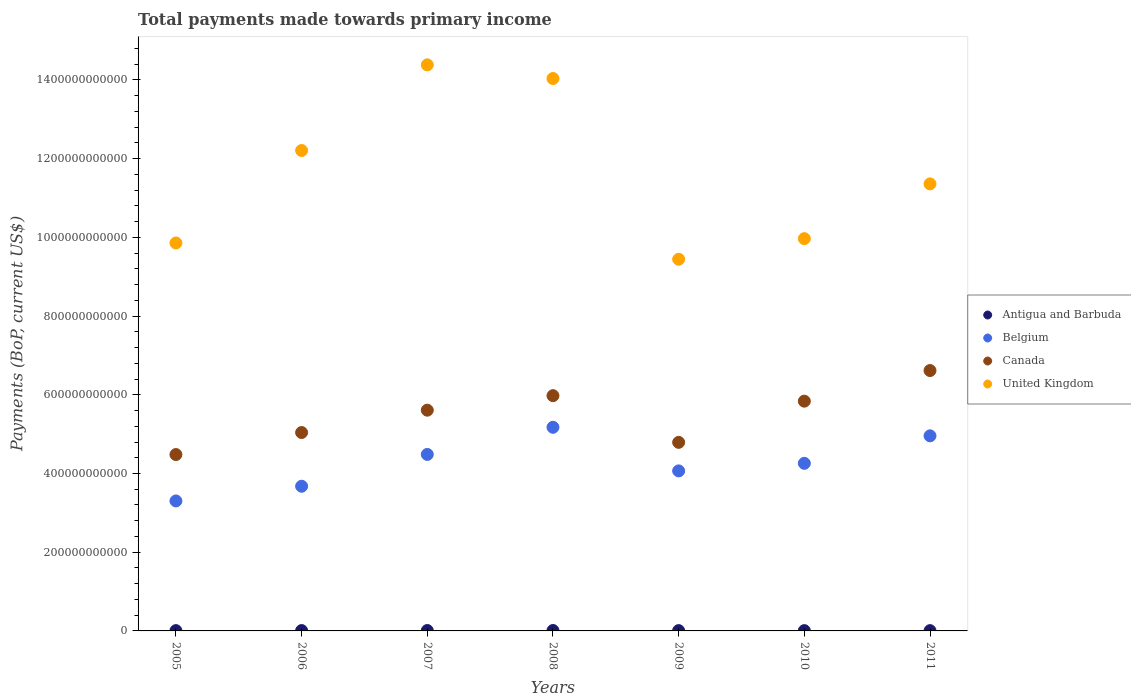How many different coloured dotlines are there?
Keep it short and to the point. 4. Is the number of dotlines equal to the number of legend labels?
Provide a succinct answer. Yes. What is the total payments made towards primary income in Belgium in 2005?
Ensure brevity in your answer.  3.30e+11. Across all years, what is the maximum total payments made towards primary income in Antigua and Barbuda?
Keep it short and to the point. 1.03e+09. Across all years, what is the minimum total payments made towards primary income in Antigua and Barbuda?
Your answer should be compact. 6.91e+08. In which year was the total payments made towards primary income in Canada minimum?
Make the answer very short. 2005. What is the total total payments made towards primary income in United Kingdom in the graph?
Make the answer very short. 8.13e+12. What is the difference between the total payments made towards primary income in Antigua and Barbuda in 2007 and that in 2010?
Your answer should be compact. 2.89e+08. What is the difference between the total payments made towards primary income in Belgium in 2006 and the total payments made towards primary income in United Kingdom in 2007?
Your answer should be very brief. -1.07e+12. What is the average total payments made towards primary income in Antigua and Barbuda per year?
Ensure brevity in your answer.  8.37e+08. In the year 2005, what is the difference between the total payments made towards primary income in Canada and total payments made towards primary income in Antigua and Barbuda?
Make the answer very short. 4.47e+11. In how many years, is the total payments made towards primary income in United Kingdom greater than 1440000000000 US$?
Provide a succinct answer. 0. What is the ratio of the total payments made towards primary income in United Kingdom in 2006 to that in 2011?
Give a very brief answer. 1.07. Is the total payments made towards primary income in Canada in 2006 less than that in 2007?
Ensure brevity in your answer.  Yes. What is the difference between the highest and the second highest total payments made towards primary income in Belgium?
Ensure brevity in your answer.  2.17e+1. What is the difference between the highest and the lowest total payments made towards primary income in United Kingdom?
Provide a succinct answer. 4.94e+11. In how many years, is the total payments made towards primary income in United Kingdom greater than the average total payments made towards primary income in United Kingdom taken over all years?
Provide a succinct answer. 3. Is it the case that in every year, the sum of the total payments made towards primary income in Antigua and Barbuda and total payments made towards primary income in United Kingdom  is greater than the total payments made towards primary income in Belgium?
Make the answer very short. Yes. Is the total payments made towards primary income in Canada strictly greater than the total payments made towards primary income in United Kingdom over the years?
Make the answer very short. No. How many years are there in the graph?
Offer a terse response. 7. What is the difference between two consecutive major ticks on the Y-axis?
Your answer should be very brief. 2.00e+11. Are the values on the major ticks of Y-axis written in scientific E-notation?
Keep it short and to the point. No. Does the graph contain any zero values?
Your answer should be very brief. No. Does the graph contain grids?
Give a very brief answer. No. Where does the legend appear in the graph?
Keep it short and to the point. Center right. How many legend labels are there?
Provide a short and direct response. 4. What is the title of the graph?
Provide a short and direct response. Total payments made towards primary income. What is the label or title of the Y-axis?
Offer a very short reply. Payments (BoP, current US$). What is the Payments (BoP, current US$) in Antigua and Barbuda in 2005?
Provide a short and direct response. 7.43e+08. What is the Payments (BoP, current US$) of Belgium in 2005?
Give a very brief answer. 3.30e+11. What is the Payments (BoP, current US$) in Canada in 2005?
Give a very brief answer. 4.48e+11. What is the Payments (BoP, current US$) of United Kingdom in 2005?
Provide a succinct answer. 9.86e+11. What is the Payments (BoP, current US$) in Antigua and Barbuda in 2006?
Give a very brief answer. 8.92e+08. What is the Payments (BoP, current US$) in Belgium in 2006?
Your answer should be compact. 3.68e+11. What is the Payments (BoP, current US$) in Canada in 2006?
Offer a very short reply. 5.04e+11. What is the Payments (BoP, current US$) of United Kingdom in 2006?
Offer a very short reply. 1.22e+12. What is the Payments (BoP, current US$) of Antigua and Barbuda in 2007?
Your answer should be compact. 1.01e+09. What is the Payments (BoP, current US$) in Belgium in 2007?
Your answer should be very brief. 4.48e+11. What is the Payments (BoP, current US$) in Canada in 2007?
Offer a very short reply. 5.61e+11. What is the Payments (BoP, current US$) in United Kingdom in 2007?
Make the answer very short. 1.44e+12. What is the Payments (BoP, current US$) in Antigua and Barbuda in 2008?
Ensure brevity in your answer.  1.03e+09. What is the Payments (BoP, current US$) of Belgium in 2008?
Keep it short and to the point. 5.17e+11. What is the Payments (BoP, current US$) of Canada in 2008?
Provide a succinct answer. 5.98e+11. What is the Payments (BoP, current US$) of United Kingdom in 2008?
Your response must be concise. 1.40e+12. What is the Payments (BoP, current US$) in Antigua and Barbuda in 2009?
Your answer should be compact. 7.70e+08. What is the Payments (BoP, current US$) in Belgium in 2009?
Your answer should be very brief. 4.07e+11. What is the Payments (BoP, current US$) in Canada in 2009?
Offer a terse response. 4.79e+11. What is the Payments (BoP, current US$) in United Kingdom in 2009?
Make the answer very short. 9.44e+11. What is the Payments (BoP, current US$) of Antigua and Barbuda in 2010?
Your response must be concise. 7.22e+08. What is the Payments (BoP, current US$) in Belgium in 2010?
Provide a short and direct response. 4.26e+11. What is the Payments (BoP, current US$) of Canada in 2010?
Provide a succinct answer. 5.84e+11. What is the Payments (BoP, current US$) in United Kingdom in 2010?
Ensure brevity in your answer.  9.97e+11. What is the Payments (BoP, current US$) of Antigua and Barbuda in 2011?
Your response must be concise. 6.91e+08. What is the Payments (BoP, current US$) in Belgium in 2011?
Offer a terse response. 4.96e+11. What is the Payments (BoP, current US$) of Canada in 2011?
Your response must be concise. 6.62e+11. What is the Payments (BoP, current US$) in United Kingdom in 2011?
Make the answer very short. 1.14e+12. Across all years, what is the maximum Payments (BoP, current US$) of Antigua and Barbuda?
Your answer should be compact. 1.03e+09. Across all years, what is the maximum Payments (BoP, current US$) in Belgium?
Ensure brevity in your answer.  5.17e+11. Across all years, what is the maximum Payments (BoP, current US$) of Canada?
Make the answer very short. 6.62e+11. Across all years, what is the maximum Payments (BoP, current US$) in United Kingdom?
Provide a short and direct response. 1.44e+12. Across all years, what is the minimum Payments (BoP, current US$) of Antigua and Barbuda?
Keep it short and to the point. 6.91e+08. Across all years, what is the minimum Payments (BoP, current US$) of Belgium?
Offer a very short reply. 3.30e+11. Across all years, what is the minimum Payments (BoP, current US$) in Canada?
Give a very brief answer. 4.48e+11. Across all years, what is the minimum Payments (BoP, current US$) of United Kingdom?
Keep it short and to the point. 9.44e+11. What is the total Payments (BoP, current US$) in Antigua and Barbuda in the graph?
Provide a succinct answer. 5.86e+09. What is the total Payments (BoP, current US$) of Belgium in the graph?
Make the answer very short. 2.99e+12. What is the total Payments (BoP, current US$) in Canada in the graph?
Provide a short and direct response. 3.84e+12. What is the total Payments (BoP, current US$) of United Kingdom in the graph?
Your answer should be compact. 8.13e+12. What is the difference between the Payments (BoP, current US$) in Antigua and Barbuda in 2005 and that in 2006?
Your answer should be very brief. -1.49e+08. What is the difference between the Payments (BoP, current US$) in Belgium in 2005 and that in 2006?
Provide a succinct answer. -3.73e+1. What is the difference between the Payments (BoP, current US$) in Canada in 2005 and that in 2006?
Provide a short and direct response. -5.59e+1. What is the difference between the Payments (BoP, current US$) of United Kingdom in 2005 and that in 2006?
Provide a succinct answer. -2.35e+11. What is the difference between the Payments (BoP, current US$) of Antigua and Barbuda in 2005 and that in 2007?
Make the answer very short. -2.68e+08. What is the difference between the Payments (BoP, current US$) of Belgium in 2005 and that in 2007?
Your answer should be very brief. -1.18e+11. What is the difference between the Payments (BoP, current US$) in Canada in 2005 and that in 2007?
Ensure brevity in your answer.  -1.13e+11. What is the difference between the Payments (BoP, current US$) of United Kingdom in 2005 and that in 2007?
Make the answer very short. -4.53e+11. What is the difference between the Payments (BoP, current US$) of Antigua and Barbuda in 2005 and that in 2008?
Offer a very short reply. -2.87e+08. What is the difference between the Payments (BoP, current US$) of Belgium in 2005 and that in 2008?
Offer a terse response. -1.87e+11. What is the difference between the Payments (BoP, current US$) in Canada in 2005 and that in 2008?
Offer a terse response. -1.50e+11. What is the difference between the Payments (BoP, current US$) of United Kingdom in 2005 and that in 2008?
Your answer should be very brief. -4.18e+11. What is the difference between the Payments (BoP, current US$) of Antigua and Barbuda in 2005 and that in 2009?
Your answer should be very brief. -2.77e+07. What is the difference between the Payments (BoP, current US$) of Belgium in 2005 and that in 2009?
Make the answer very short. -7.63e+1. What is the difference between the Payments (BoP, current US$) of Canada in 2005 and that in 2009?
Make the answer very short. -3.10e+1. What is the difference between the Payments (BoP, current US$) in United Kingdom in 2005 and that in 2009?
Make the answer very short. 4.14e+1. What is the difference between the Payments (BoP, current US$) of Antigua and Barbuda in 2005 and that in 2010?
Give a very brief answer. 2.12e+07. What is the difference between the Payments (BoP, current US$) of Belgium in 2005 and that in 2010?
Make the answer very short. -9.56e+1. What is the difference between the Payments (BoP, current US$) in Canada in 2005 and that in 2010?
Your response must be concise. -1.36e+11. What is the difference between the Payments (BoP, current US$) of United Kingdom in 2005 and that in 2010?
Offer a very short reply. -1.10e+1. What is the difference between the Payments (BoP, current US$) in Antigua and Barbuda in 2005 and that in 2011?
Offer a terse response. 5.14e+07. What is the difference between the Payments (BoP, current US$) of Belgium in 2005 and that in 2011?
Offer a very short reply. -1.65e+11. What is the difference between the Payments (BoP, current US$) of Canada in 2005 and that in 2011?
Give a very brief answer. -2.13e+11. What is the difference between the Payments (BoP, current US$) of United Kingdom in 2005 and that in 2011?
Offer a terse response. -1.50e+11. What is the difference between the Payments (BoP, current US$) of Antigua and Barbuda in 2006 and that in 2007?
Offer a very short reply. -1.19e+08. What is the difference between the Payments (BoP, current US$) in Belgium in 2006 and that in 2007?
Your answer should be compact. -8.08e+1. What is the difference between the Payments (BoP, current US$) of Canada in 2006 and that in 2007?
Your answer should be compact. -5.68e+1. What is the difference between the Payments (BoP, current US$) of United Kingdom in 2006 and that in 2007?
Your response must be concise. -2.18e+11. What is the difference between the Payments (BoP, current US$) of Antigua and Barbuda in 2006 and that in 2008?
Provide a short and direct response. -1.38e+08. What is the difference between the Payments (BoP, current US$) of Belgium in 2006 and that in 2008?
Provide a succinct answer. -1.50e+11. What is the difference between the Payments (BoP, current US$) of Canada in 2006 and that in 2008?
Offer a very short reply. -9.37e+1. What is the difference between the Payments (BoP, current US$) in United Kingdom in 2006 and that in 2008?
Ensure brevity in your answer.  -1.83e+11. What is the difference between the Payments (BoP, current US$) of Antigua and Barbuda in 2006 and that in 2009?
Give a very brief answer. 1.21e+08. What is the difference between the Payments (BoP, current US$) in Belgium in 2006 and that in 2009?
Your answer should be very brief. -3.90e+1. What is the difference between the Payments (BoP, current US$) of Canada in 2006 and that in 2009?
Your response must be concise. 2.50e+1. What is the difference between the Payments (BoP, current US$) of United Kingdom in 2006 and that in 2009?
Make the answer very short. 2.76e+11. What is the difference between the Payments (BoP, current US$) in Antigua and Barbuda in 2006 and that in 2010?
Make the answer very short. 1.70e+08. What is the difference between the Payments (BoP, current US$) in Belgium in 2006 and that in 2010?
Provide a succinct answer. -5.82e+1. What is the difference between the Payments (BoP, current US$) in Canada in 2006 and that in 2010?
Offer a terse response. -7.97e+1. What is the difference between the Payments (BoP, current US$) of United Kingdom in 2006 and that in 2010?
Give a very brief answer. 2.24e+11. What is the difference between the Payments (BoP, current US$) in Antigua and Barbuda in 2006 and that in 2011?
Provide a succinct answer. 2.01e+08. What is the difference between the Payments (BoP, current US$) of Belgium in 2006 and that in 2011?
Your answer should be compact. -1.28e+11. What is the difference between the Payments (BoP, current US$) of Canada in 2006 and that in 2011?
Offer a terse response. -1.58e+11. What is the difference between the Payments (BoP, current US$) in United Kingdom in 2006 and that in 2011?
Your answer should be very brief. 8.48e+1. What is the difference between the Payments (BoP, current US$) of Antigua and Barbuda in 2007 and that in 2008?
Give a very brief answer. -1.86e+07. What is the difference between the Payments (BoP, current US$) of Belgium in 2007 and that in 2008?
Your answer should be very brief. -6.90e+1. What is the difference between the Payments (BoP, current US$) in Canada in 2007 and that in 2008?
Provide a succinct answer. -3.69e+1. What is the difference between the Payments (BoP, current US$) of United Kingdom in 2007 and that in 2008?
Keep it short and to the point. 3.47e+1. What is the difference between the Payments (BoP, current US$) in Antigua and Barbuda in 2007 and that in 2009?
Your answer should be very brief. 2.40e+08. What is the difference between the Payments (BoP, current US$) of Belgium in 2007 and that in 2009?
Provide a succinct answer. 4.18e+1. What is the difference between the Payments (BoP, current US$) of Canada in 2007 and that in 2009?
Your response must be concise. 8.17e+1. What is the difference between the Payments (BoP, current US$) in United Kingdom in 2007 and that in 2009?
Keep it short and to the point. 4.94e+11. What is the difference between the Payments (BoP, current US$) of Antigua and Barbuda in 2007 and that in 2010?
Provide a succinct answer. 2.89e+08. What is the difference between the Payments (BoP, current US$) in Belgium in 2007 and that in 2010?
Ensure brevity in your answer.  2.26e+1. What is the difference between the Payments (BoP, current US$) of Canada in 2007 and that in 2010?
Offer a terse response. -2.29e+1. What is the difference between the Payments (BoP, current US$) of United Kingdom in 2007 and that in 2010?
Give a very brief answer. 4.42e+11. What is the difference between the Payments (BoP, current US$) of Antigua and Barbuda in 2007 and that in 2011?
Your response must be concise. 3.19e+08. What is the difference between the Payments (BoP, current US$) of Belgium in 2007 and that in 2011?
Your answer should be very brief. -4.73e+1. What is the difference between the Payments (BoP, current US$) in Canada in 2007 and that in 2011?
Give a very brief answer. -1.01e+11. What is the difference between the Payments (BoP, current US$) of United Kingdom in 2007 and that in 2011?
Your answer should be compact. 3.02e+11. What is the difference between the Payments (BoP, current US$) of Antigua and Barbuda in 2008 and that in 2009?
Keep it short and to the point. 2.59e+08. What is the difference between the Payments (BoP, current US$) of Belgium in 2008 and that in 2009?
Make the answer very short. 1.11e+11. What is the difference between the Payments (BoP, current US$) in Canada in 2008 and that in 2009?
Offer a terse response. 1.19e+11. What is the difference between the Payments (BoP, current US$) in United Kingdom in 2008 and that in 2009?
Keep it short and to the point. 4.59e+11. What is the difference between the Payments (BoP, current US$) of Antigua and Barbuda in 2008 and that in 2010?
Offer a very short reply. 3.08e+08. What is the difference between the Payments (BoP, current US$) in Belgium in 2008 and that in 2010?
Your answer should be very brief. 9.16e+1. What is the difference between the Payments (BoP, current US$) in Canada in 2008 and that in 2010?
Your response must be concise. 1.40e+1. What is the difference between the Payments (BoP, current US$) in United Kingdom in 2008 and that in 2010?
Your answer should be compact. 4.07e+11. What is the difference between the Payments (BoP, current US$) of Antigua and Barbuda in 2008 and that in 2011?
Ensure brevity in your answer.  3.38e+08. What is the difference between the Payments (BoP, current US$) of Belgium in 2008 and that in 2011?
Your answer should be compact. 2.17e+1. What is the difference between the Payments (BoP, current US$) in Canada in 2008 and that in 2011?
Ensure brevity in your answer.  -6.38e+1. What is the difference between the Payments (BoP, current US$) of United Kingdom in 2008 and that in 2011?
Your answer should be very brief. 2.68e+11. What is the difference between the Payments (BoP, current US$) in Antigua and Barbuda in 2009 and that in 2010?
Your answer should be compact. 4.88e+07. What is the difference between the Payments (BoP, current US$) of Belgium in 2009 and that in 2010?
Offer a terse response. -1.92e+1. What is the difference between the Payments (BoP, current US$) of Canada in 2009 and that in 2010?
Make the answer very short. -1.05e+11. What is the difference between the Payments (BoP, current US$) in United Kingdom in 2009 and that in 2010?
Offer a terse response. -5.24e+1. What is the difference between the Payments (BoP, current US$) in Antigua and Barbuda in 2009 and that in 2011?
Provide a short and direct response. 7.91e+07. What is the difference between the Payments (BoP, current US$) of Belgium in 2009 and that in 2011?
Your answer should be very brief. -8.91e+1. What is the difference between the Payments (BoP, current US$) in Canada in 2009 and that in 2011?
Make the answer very short. -1.82e+11. What is the difference between the Payments (BoP, current US$) in United Kingdom in 2009 and that in 2011?
Your answer should be compact. -1.92e+11. What is the difference between the Payments (BoP, current US$) in Antigua and Barbuda in 2010 and that in 2011?
Keep it short and to the point. 3.02e+07. What is the difference between the Payments (BoP, current US$) of Belgium in 2010 and that in 2011?
Provide a short and direct response. -6.99e+1. What is the difference between the Payments (BoP, current US$) of Canada in 2010 and that in 2011?
Keep it short and to the point. -7.78e+1. What is the difference between the Payments (BoP, current US$) of United Kingdom in 2010 and that in 2011?
Ensure brevity in your answer.  -1.39e+11. What is the difference between the Payments (BoP, current US$) in Antigua and Barbuda in 2005 and the Payments (BoP, current US$) in Belgium in 2006?
Your answer should be compact. -3.67e+11. What is the difference between the Payments (BoP, current US$) of Antigua and Barbuda in 2005 and the Payments (BoP, current US$) of Canada in 2006?
Offer a terse response. -5.03e+11. What is the difference between the Payments (BoP, current US$) of Antigua and Barbuda in 2005 and the Payments (BoP, current US$) of United Kingdom in 2006?
Your response must be concise. -1.22e+12. What is the difference between the Payments (BoP, current US$) of Belgium in 2005 and the Payments (BoP, current US$) of Canada in 2006?
Ensure brevity in your answer.  -1.74e+11. What is the difference between the Payments (BoP, current US$) in Belgium in 2005 and the Payments (BoP, current US$) in United Kingdom in 2006?
Your response must be concise. -8.90e+11. What is the difference between the Payments (BoP, current US$) in Canada in 2005 and the Payments (BoP, current US$) in United Kingdom in 2006?
Offer a very short reply. -7.73e+11. What is the difference between the Payments (BoP, current US$) in Antigua and Barbuda in 2005 and the Payments (BoP, current US$) in Belgium in 2007?
Ensure brevity in your answer.  -4.48e+11. What is the difference between the Payments (BoP, current US$) of Antigua and Barbuda in 2005 and the Payments (BoP, current US$) of Canada in 2007?
Provide a short and direct response. -5.60e+11. What is the difference between the Payments (BoP, current US$) of Antigua and Barbuda in 2005 and the Payments (BoP, current US$) of United Kingdom in 2007?
Offer a very short reply. -1.44e+12. What is the difference between the Payments (BoP, current US$) of Belgium in 2005 and the Payments (BoP, current US$) of Canada in 2007?
Keep it short and to the point. -2.31e+11. What is the difference between the Payments (BoP, current US$) in Belgium in 2005 and the Payments (BoP, current US$) in United Kingdom in 2007?
Keep it short and to the point. -1.11e+12. What is the difference between the Payments (BoP, current US$) of Canada in 2005 and the Payments (BoP, current US$) of United Kingdom in 2007?
Your response must be concise. -9.90e+11. What is the difference between the Payments (BoP, current US$) of Antigua and Barbuda in 2005 and the Payments (BoP, current US$) of Belgium in 2008?
Your response must be concise. -5.17e+11. What is the difference between the Payments (BoP, current US$) of Antigua and Barbuda in 2005 and the Payments (BoP, current US$) of Canada in 2008?
Make the answer very short. -5.97e+11. What is the difference between the Payments (BoP, current US$) in Antigua and Barbuda in 2005 and the Payments (BoP, current US$) in United Kingdom in 2008?
Make the answer very short. -1.40e+12. What is the difference between the Payments (BoP, current US$) of Belgium in 2005 and the Payments (BoP, current US$) of Canada in 2008?
Offer a very short reply. -2.67e+11. What is the difference between the Payments (BoP, current US$) in Belgium in 2005 and the Payments (BoP, current US$) in United Kingdom in 2008?
Provide a short and direct response. -1.07e+12. What is the difference between the Payments (BoP, current US$) of Canada in 2005 and the Payments (BoP, current US$) of United Kingdom in 2008?
Ensure brevity in your answer.  -9.55e+11. What is the difference between the Payments (BoP, current US$) of Antigua and Barbuda in 2005 and the Payments (BoP, current US$) of Belgium in 2009?
Provide a short and direct response. -4.06e+11. What is the difference between the Payments (BoP, current US$) in Antigua and Barbuda in 2005 and the Payments (BoP, current US$) in Canada in 2009?
Provide a short and direct response. -4.78e+11. What is the difference between the Payments (BoP, current US$) in Antigua and Barbuda in 2005 and the Payments (BoP, current US$) in United Kingdom in 2009?
Give a very brief answer. -9.44e+11. What is the difference between the Payments (BoP, current US$) of Belgium in 2005 and the Payments (BoP, current US$) of Canada in 2009?
Your response must be concise. -1.49e+11. What is the difference between the Payments (BoP, current US$) in Belgium in 2005 and the Payments (BoP, current US$) in United Kingdom in 2009?
Provide a succinct answer. -6.14e+11. What is the difference between the Payments (BoP, current US$) in Canada in 2005 and the Payments (BoP, current US$) in United Kingdom in 2009?
Ensure brevity in your answer.  -4.96e+11. What is the difference between the Payments (BoP, current US$) of Antigua and Barbuda in 2005 and the Payments (BoP, current US$) of Belgium in 2010?
Your answer should be very brief. -4.25e+11. What is the difference between the Payments (BoP, current US$) of Antigua and Barbuda in 2005 and the Payments (BoP, current US$) of Canada in 2010?
Offer a terse response. -5.83e+11. What is the difference between the Payments (BoP, current US$) in Antigua and Barbuda in 2005 and the Payments (BoP, current US$) in United Kingdom in 2010?
Ensure brevity in your answer.  -9.96e+11. What is the difference between the Payments (BoP, current US$) of Belgium in 2005 and the Payments (BoP, current US$) of Canada in 2010?
Your response must be concise. -2.54e+11. What is the difference between the Payments (BoP, current US$) in Belgium in 2005 and the Payments (BoP, current US$) in United Kingdom in 2010?
Make the answer very short. -6.66e+11. What is the difference between the Payments (BoP, current US$) of Canada in 2005 and the Payments (BoP, current US$) of United Kingdom in 2010?
Provide a succinct answer. -5.49e+11. What is the difference between the Payments (BoP, current US$) in Antigua and Barbuda in 2005 and the Payments (BoP, current US$) in Belgium in 2011?
Offer a very short reply. -4.95e+11. What is the difference between the Payments (BoP, current US$) of Antigua and Barbuda in 2005 and the Payments (BoP, current US$) of Canada in 2011?
Your response must be concise. -6.61e+11. What is the difference between the Payments (BoP, current US$) in Antigua and Barbuda in 2005 and the Payments (BoP, current US$) in United Kingdom in 2011?
Offer a terse response. -1.14e+12. What is the difference between the Payments (BoP, current US$) of Belgium in 2005 and the Payments (BoP, current US$) of Canada in 2011?
Offer a terse response. -3.31e+11. What is the difference between the Payments (BoP, current US$) of Belgium in 2005 and the Payments (BoP, current US$) of United Kingdom in 2011?
Ensure brevity in your answer.  -8.06e+11. What is the difference between the Payments (BoP, current US$) in Canada in 2005 and the Payments (BoP, current US$) in United Kingdom in 2011?
Offer a very short reply. -6.88e+11. What is the difference between the Payments (BoP, current US$) of Antigua and Barbuda in 2006 and the Payments (BoP, current US$) of Belgium in 2007?
Give a very brief answer. -4.48e+11. What is the difference between the Payments (BoP, current US$) in Antigua and Barbuda in 2006 and the Payments (BoP, current US$) in Canada in 2007?
Provide a short and direct response. -5.60e+11. What is the difference between the Payments (BoP, current US$) in Antigua and Barbuda in 2006 and the Payments (BoP, current US$) in United Kingdom in 2007?
Provide a short and direct response. -1.44e+12. What is the difference between the Payments (BoP, current US$) in Belgium in 2006 and the Payments (BoP, current US$) in Canada in 2007?
Provide a succinct answer. -1.93e+11. What is the difference between the Payments (BoP, current US$) in Belgium in 2006 and the Payments (BoP, current US$) in United Kingdom in 2007?
Give a very brief answer. -1.07e+12. What is the difference between the Payments (BoP, current US$) in Canada in 2006 and the Payments (BoP, current US$) in United Kingdom in 2007?
Ensure brevity in your answer.  -9.34e+11. What is the difference between the Payments (BoP, current US$) of Antigua and Barbuda in 2006 and the Payments (BoP, current US$) of Belgium in 2008?
Offer a very short reply. -5.17e+11. What is the difference between the Payments (BoP, current US$) in Antigua and Barbuda in 2006 and the Payments (BoP, current US$) in Canada in 2008?
Your answer should be very brief. -5.97e+11. What is the difference between the Payments (BoP, current US$) of Antigua and Barbuda in 2006 and the Payments (BoP, current US$) of United Kingdom in 2008?
Make the answer very short. -1.40e+12. What is the difference between the Payments (BoP, current US$) of Belgium in 2006 and the Payments (BoP, current US$) of Canada in 2008?
Ensure brevity in your answer.  -2.30e+11. What is the difference between the Payments (BoP, current US$) in Belgium in 2006 and the Payments (BoP, current US$) in United Kingdom in 2008?
Provide a succinct answer. -1.04e+12. What is the difference between the Payments (BoP, current US$) in Canada in 2006 and the Payments (BoP, current US$) in United Kingdom in 2008?
Give a very brief answer. -9.00e+11. What is the difference between the Payments (BoP, current US$) of Antigua and Barbuda in 2006 and the Payments (BoP, current US$) of Belgium in 2009?
Provide a short and direct response. -4.06e+11. What is the difference between the Payments (BoP, current US$) in Antigua and Barbuda in 2006 and the Payments (BoP, current US$) in Canada in 2009?
Your response must be concise. -4.78e+11. What is the difference between the Payments (BoP, current US$) in Antigua and Barbuda in 2006 and the Payments (BoP, current US$) in United Kingdom in 2009?
Your response must be concise. -9.43e+11. What is the difference between the Payments (BoP, current US$) in Belgium in 2006 and the Payments (BoP, current US$) in Canada in 2009?
Make the answer very short. -1.12e+11. What is the difference between the Payments (BoP, current US$) of Belgium in 2006 and the Payments (BoP, current US$) of United Kingdom in 2009?
Your response must be concise. -5.77e+11. What is the difference between the Payments (BoP, current US$) in Canada in 2006 and the Payments (BoP, current US$) in United Kingdom in 2009?
Your answer should be compact. -4.40e+11. What is the difference between the Payments (BoP, current US$) in Antigua and Barbuda in 2006 and the Payments (BoP, current US$) in Belgium in 2010?
Your answer should be compact. -4.25e+11. What is the difference between the Payments (BoP, current US$) in Antigua and Barbuda in 2006 and the Payments (BoP, current US$) in Canada in 2010?
Offer a terse response. -5.83e+11. What is the difference between the Payments (BoP, current US$) in Antigua and Barbuda in 2006 and the Payments (BoP, current US$) in United Kingdom in 2010?
Provide a short and direct response. -9.96e+11. What is the difference between the Payments (BoP, current US$) in Belgium in 2006 and the Payments (BoP, current US$) in Canada in 2010?
Ensure brevity in your answer.  -2.16e+11. What is the difference between the Payments (BoP, current US$) of Belgium in 2006 and the Payments (BoP, current US$) of United Kingdom in 2010?
Ensure brevity in your answer.  -6.29e+11. What is the difference between the Payments (BoP, current US$) in Canada in 2006 and the Payments (BoP, current US$) in United Kingdom in 2010?
Your answer should be very brief. -4.93e+11. What is the difference between the Payments (BoP, current US$) of Antigua and Barbuda in 2006 and the Payments (BoP, current US$) of Belgium in 2011?
Make the answer very short. -4.95e+11. What is the difference between the Payments (BoP, current US$) of Antigua and Barbuda in 2006 and the Payments (BoP, current US$) of Canada in 2011?
Offer a very short reply. -6.61e+11. What is the difference between the Payments (BoP, current US$) in Antigua and Barbuda in 2006 and the Payments (BoP, current US$) in United Kingdom in 2011?
Your answer should be very brief. -1.14e+12. What is the difference between the Payments (BoP, current US$) in Belgium in 2006 and the Payments (BoP, current US$) in Canada in 2011?
Keep it short and to the point. -2.94e+11. What is the difference between the Payments (BoP, current US$) of Belgium in 2006 and the Payments (BoP, current US$) of United Kingdom in 2011?
Your answer should be compact. -7.68e+11. What is the difference between the Payments (BoP, current US$) in Canada in 2006 and the Payments (BoP, current US$) in United Kingdom in 2011?
Your answer should be very brief. -6.32e+11. What is the difference between the Payments (BoP, current US$) of Antigua and Barbuda in 2007 and the Payments (BoP, current US$) of Belgium in 2008?
Your answer should be very brief. -5.16e+11. What is the difference between the Payments (BoP, current US$) in Antigua and Barbuda in 2007 and the Payments (BoP, current US$) in Canada in 2008?
Make the answer very short. -5.97e+11. What is the difference between the Payments (BoP, current US$) of Antigua and Barbuda in 2007 and the Payments (BoP, current US$) of United Kingdom in 2008?
Provide a succinct answer. -1.40e+12. What is the difference between the Payments (BoP, current US$) of Belgium in 2007 and the Payments (BoP, current US$) of Canada in 2008?
Offer a very short reply. -1.49e+11. What is the difference between the Payments (BoP, current US$) of Belgium in 2007 and the Payments (BoP, current US$) of United Kingdom in 2008?
Ensure brevity in your answer.  -9.55e+11. What is the difference between the Payments (BoP, current US$) in Canada in 2007 and the Payments (BoP, current US$) in United Kingdom in 2008?
Provide a short and direct response. -8.43e+11. What is the difference between the Payments (BoP, current US$) in Antigua and Barbuda in 2007 and the Payments (BoP, current US$) in Belgium in 2009?
Give a very brief answer. -4.06e+11. What is the difference between the Payments (BoP, current US$) in Antigua and Barbuda in 2007 and the Payments (BoP, current US$) in Canada in 2009?
Provide a succinct answer. -4.78e+11. What is the difference between the Payments (BoP, current US$) in Antigua and Barbuda in 2007 and the Payments (BoP, current US$) in United Kingdom in 2009?
Provide a short and direct response. -9.43e+11. What is the difference between the Payments (BoP, current US$) of Belgium in 2007 and the Payments (BoP, current US$) of Canada in 2009?
Offer a terse response. -3.07e+1. What is the difference between the Payments (BoP, current US$) of Belgium in 2007 and the Payments (BoP, current US$) of United Kingdom in 2009?
Provide a short and direct response. -4.96e+11. What is the difference between the Payments (BoP, current US$) in Canada in 2007 and the Payments (BoP, current US$) in United Kingdom in 2009?
Your response must be concise. -3.83e+11. What is the difference between the Payments (BoP, current US$) of Antigua and Barbuda in 2007 and the Payments (BoP, current US$) of Belgium in 2010?
Provide a short and direct response. -4.25e+11. What is the difference between the Payments (BoP, current US$) in Antigua and Barbuda in 2007 and the Payments (BoP, current US$) in Canada in 2010?
Offer a terse response. -5.83e+11. What is the difference between the Payments (BoP, current US$) of Antigua and Barbuda in 2007 and the Payments (BoP, current US$) of United Kingdom in 2010?
Provide a short and direct response. -9.96e+11. What is the difference between the Payments (BoP, current US$) of Belgium in 2007 and the Payments (BoP, current US$) of Canada in 2010?
Offer a very short reply. -1.35e+11. What is the difference between the Payments (BoP, current US$) in Belgium in 2007 and the Payments (BoP, current US$) in United Kingdom in 2010?
Keep it short and to the point. -5.48e+11. What is the difference between the Payments (BoP, current US$) of Canada in 2007 and the Payments (BoP, current US$) of United Kingdom in 2010?
Your response must be concise. -4.36e+11. What is the difference between the Payments (BoP, current US$) in Antigua and Barbuda in 2007 and the Payments (BoP, current US$) in Belgium in 2011?
Keep it short and to the point. -4.95e+11. What is the difference between the Payments (BoP, current US$) in Antigua and Barbuda in 2007 and the Payments (BoP, current US$) in Canada in 2011?
Offer a very short reply. -6.61e+11. What is the difference between the Payments (BoP, current US$) in Antigua and Barbuda in 2007 and the Payments (BoP, current US$) in United Kingdom in 2011?
Give a very brief answer. -1.13e+12. What is the difference between the Payments (BoP, current US$) in Belgium in 2007 and the Payments (BoP, current US$) in Canada in 2011?
Your answer should be compact. -2.13e+11. What is the difference between the Payments (BoP, current US$) in Belgium in 2007 and the Payments (BoP, current US$) in United Kingdom in 2011?
Your response must be concise. -6.87e+11. What is the difference between the Payments (BoP, current US$) in Canada in 2007 and the Payments (BoP, current US$) in United Kingdom in 2011?
Your answer should be compact. -5.75e+11. What is the difference between the Payments (BoP, current US$) of Antigua and Barbuda in 2008 and the Payments (BoP, current US$) of Belgium in 2009?
Your answer should be compact. -4.06e+11. What is the difference between the Payments (BoP, current US$) in Antigua and Barbuda in 2008 and the Payments (BoP, current US$) in Canada in 2009?
Provide a succinct answer. -4.78e+11. What is the difference between the Payments (BoP, current US$) of Antigua and Barbuda in 2008 and the Payments (BoP, current US$) of United Kingdom in 2009?
Your answer should be compact. -9.43e+11. What is the difference between the Payments (BoP, current US$) of Belgium in 2008 and the Payments (BoP, current US$) of Canada in 2009?
Keep it short and to the point. 3.83e+1. What is the difference between the Payments (BoP, current US$) of Belgium in 2008 and the Payments (BoP, current US$) of United Kingdom in 2009?
Provide a short and direct response. -4.27e+11. What is the difference between the Payments (BoP, current US$) in Canada in 2008 and the Payments (BoP, current US$) in United Kingdom in 2009?
Your answer should be compact. -3.47e+11. What is the difference between the Payments (BoP, current US$) in Antigua and Barbuda in 2008 and the Payments (BoP, current US$) in Belgium in 2010?
Your response must be concise. -4.25e+11. What is the difference between the Payments (BoP, current US$) of Antigua and Barbuda in 2008 and the Payments (BoP, current US$) of Canada in 2010?
Offer a terse response. -5.83e+11. What is the difference between the Payments (BoP, current US$) of Antigua and Barbuda in 2008 and the Payments (BoP, current US$) of United Kingdom in 2010?
Ensure brevity in your answer.  -9.96e+11. What is the difference between the Payments (BoP, current US$) in Belgium in 2008 and the Payments (BoP, current US$) in Canada in 2010?
Offer a terse response. -6.64e+1. What is the difference between the Payments (BoP, current US$) of Belgium in 2008 and the Payments (BoP, current US$) of United Kingdom in 2010?
Your answer should be very brief. -4.79e+11. What is the difference between the Payments (BoP, current US$) in Canada in 2008 and the Payments (BoP, current US$) in United Kingdom in 2010?
Provide a short and direct response. -3.99e+11. What is the difference between the Payments (BoP, current US$) of Antigua and Barbuda in 2008 and the Payments (BoP, current US$) of Belgium in 2011?
Offer a terse response. -4.95e+11. What is the difference between the Payments (BoP, current US$) of Antigua and Barbuda in 2008 and the Payments (BoP, current US$) of Canada in 2011?
Provide a succinct answer. -6.61e+11. What is the difference between the Payments (BoP, current US$) of Antigua and Barbuda in 2008 and the Payments (BoP, current US$) of United Kingdom in 2011?
Give a very brief answer. -1.13e+12. What is the difference between the Payments (BoP, current US$) in Belgium in 2008 and the Payments (BoP, current US$) in Canada in 2011?
Make the answer very short. -1.44e+11. What is the difference between the Payments (BoP, current US$) of Belgium in 2008 and the Payments (BoP, current US$) of United Kingdom in 2011?
Your answer should be compact. -6.18e+11. What is the difference between the Payments (BoP, current US$) in Canada in 2008 and the Payments (BoP, current US$) in United Kingdom in 2011?
Offer a very short reply. -5.38e+11. What is the difference between the Payments (BoP, current US$) in Antigua and Barbuda in 2009 and the Payments (BoP, current US$) in Belgium in 2010?
Your response must be concise. -4.25e+11. What is the difference between the Payments (BoP, current US$) in Antigua and Barbuda in 2009 and the Payments (BoP, current US$) in Canada in 2010?
Offer a very short reply. -5.83e+11. What is the difference between the Payments (BoP, current US$) in Antigua and Barbuda in 2009 and the Payments (BoP, current US$) in United Kingdom in 2010?
Make the answer very short. -9.96e+11. What is the difference between the Payments (BoP, current US$) of Belgium in 2009 and the Payments (BoP, current US$) of Canada in 2010?
Ensure brevity in your answer.  -1.77e+11. What is the difference between the Payments (BoP, current US$) in Belgium in 2009 and the Payments (BoP, current US$) in United Kingdom in 2010?
Your answer should be compact. -5.90e+11. What is the difference between the Payments (BoP, current US$) of Canada in 2009 and the Payments (BoP, current US$) of United Kingdom in 2010?
Your response must be concise. -5.18e+11. What is the difference between the Payments (BoP, current US$) in Antigua and Barbuda in 2009 and the Payments (BoP, current US$) in Belgium in 2011?
Your answer should be very brief. -4.95e+11. What is the difference between the Payments (BoP, current US$) of Antigua and Barbuda in 2009 and the Payments (BoP, current US$) of Canada in 2011?
Provide a short and direct response. -6.61e+11. What is the difference between the Payments (BoP, current US$) in Antigua and Barbuda in 2009 and the Payments (BoP, current US$) in United Kingdom in 2011?
Your response must be concise. -1.14e+12. What is the difference between the Payments (BoP, current US$) of Belgium in 2009 and the Payments (BoP, current US$) of Canada in 2011?
Give a very brief answer. -2.55e+11. What is the difference between the Payments (BoP, current US$) in Belgium in 2009 and the Payments (BoP, current US$) in United Kingdom in 2011?
Offer a very short reply. -7.29e+11. What is the difference between the Payments (BoP, current US$) of Canada in 2009 and the Payments (BoP, current US$) of United Kingdom in 2011?
Provide a succinct answer. -6.57e+11. What is the difference between the Payments (BoP, current US$) of Antigua and Barbuda in 2010 and the Payments (BoP, current US$) of Belgium in 2011?
Provide a short and direct response. -4.95e+11. What is the difference between the Payments (BoP, current US$) in Antigua and Barbuda in 2010 and the Payments (BoP, current US$) in Canada in 2011?
Offer a terse response. -6.61e+11. What is the difference between the Payments (BoP, current US$) of Antigua and Barbuda in 2010 and the Payments (BoP, current US$) of United Kingdom in 2011?
Ensure brevity in your answer.  -1.14e+12. What is the difference between the Payments (BoP, current US$) in Belgium in 2010 and the Payments (BoP, current US$) in Canada in 2011?
Your answer should be very brief. -2.36e+11. What is the difference between the Payments (BoP, current US$) of Belgium in 2010 and the Payments (BoP, current US$) of United Kingdom in 2011?
Provide a succinct answer. -7.10e+11. What is the difference between the Payments (BoP, current US$) in Canada in 2010 and the Payments (BoP, current US$) in United Kingdom in 2011?
Offer a terse response. -5.52e+11. What is the average Payments (BoP, current US$) of Antigua and Barbuda per year?
Keep it short and to the point. 8.37e+08. What is the average Payments (BoP, current US$) in Belgium per year?
Provide a succinct answer. 4.27e+11. What is the average Payments (BoP, current US$) of Canada per year?
Your answer should be compact. 5.48e+11. What is the average Payments (BoP, current US$) in United Kingdom per year?
Provide a succinct answer. 1.16e+12. In the year 2005, what is the difference between the Payments (BoP, current US$) of Antigua and Barbuda and Payments (BoP, current US$) of Belgium?
Make the answer very short. -3.30e+11. In the year 2005, what is the difference between the Payments (BoP, current US$) of Antigua and Barbuda and Payments (BoP, current US$) of Canada?
Your answer should be very brief. -4.47e+11. In the year 2005, what is the difference between the Payments (BoP, current US$) in Antigua and Barbuda and Payments (BoP, current US$) in United Kingdom?
Your answer should be very brief. -9.85e+11. In the year 2005, what is the difference between the Payments (BoP, current US$) in Belgium and Payments (BoP, current US$) in Canada?
Your answer should be very brief. -1.18e+11. In the year 2005, what is the difference between the Payments (BoP, current US$) in Belgium and Payments (BoP, current US$) in United Kingdom?
Make the answer very short. -6.55e+11. In the year 2005, what is the difference between the Payments (BoP, current US$) in Canada and Payments (BoP, current US$) in United Kingdom?
Provide a short and direct response. -5.38e+11. In the year 2006, what is the difference between the Payments (BoP, current US$) in Antigua and Barbuda and Payments (BoP, current US$) in Belgium?
Offer a very short reply. -3.67e+11. In the year 2006, what is the difference between the Payments (BoP, current US$) in Antigua and Barbuda and Payments (BoP, current US$) in Canada?
Your answer should be compact. -5.03e+11. In the year 2006, what is the difference between the Payments (BoP, current US$) of Antigua and Barbuda and Payments (BoP, current US$) of United Kingdom?
Give a very brief answer. -1.22e+12. In the year 2006, what is the difference between the Payments (BoP, current US$) of Belgium and Payments (BoP, current US$) of Canada?
Give a very brief answer. -1.36e+11. In the year 2006, what is the difference between the Payments (BoP, current US$) in Belgium and Payments (BoP, current US$) in United Kingdom?
Offer a terse response. -8.53e+11. In the year 2006, what is the difference between the Payments (BoP, current US$) of Canada and Payments (BoP, current US$) of United Kingdom?
Provide a short and direct response. -7.17e+11. In the year 2007, what is the difference between the Payments (BoP, current US$) of Antigua and Barbuda and Payments (BoP, current US$) of Belgium?
Provide a short and direct response. -4.47e+11. In the year 2007, what is the difference between the Payments (BoP, current US$) of Antigua and Barbuda and Payments (BoP, current US$) of Canada?
Provide a succinct answer. -5.60e+11. In the year 2007, what is the difference between the Payments (BoP, current US$) of Antigua and Barbuda and Payments (BoP, current US$) of United Kingdom?
Provide a succinct answer. -1.44e+12. In the year 2007, what is the difference between the Payments (BoP, current US$) in Belgium and Payments (BoP, current US$) in Canada?
Provide a succinct answer. -1.12e+11. In the year 2007, what is the difference between the Payments (BoP, current US$) in Belgium and Payments (BoP, current US$) in United Kingdom?
Keep it short and to the point. -9.90e+11. In the year 2007, what is the difference between the Payments (BoP, current US$) of Canada and Payments (BoP, current US$) of United Kingdom?
Keep it short and to the point. -8.77e+11. In the year 2008, what is the difference between the Payments (BoP, current US$) in Antigua and Barbuda and Payments (BoP, current US$) in Belgium?
Offer a terse response. -5.16e+11. In the year 2008, what is the difference between the Payments (BoP, current US$) in Antigua and Barbuda and Payments (BoP, current US$) in Canada?
Make the answer very short. -5.97e+11. In the year 2008, what is the difference between the Payments (BoP, current US$) of Antigua and Barbuda and Payments (BoP, current US$) of United Kingdom?
Provide a short and direct response. -1.40e+12. In the year 2008, what is the difference between the Payments (BoP, current US$) in Belgium and Payments (BoP, current US$) in Canada?
Make the answer very short. -8.03e+1. In the year 2008, what is the difference between the Payments (BoP, current US$) in Belgium and Payments (BoP, current US$) in United Kingdom?
Ensure brevity in your answer.  -8.86e+11. In the year 2008, what is the difference between the Payments (BoP, current US$) of Canada and Payments (BoP, current US$) of United Kingdom?
Give a very brief answer. -8.06e+11. In the year 2009, what is the difference between the Payments (BoP, current US$) of Antigua and Barbuda and Payments (BoP, current US$) of Belgium?
Your answer should be very brief. -4.06e+11. In the year 2009, what is the difference between the Payments (BoP, current US$) of Antigua and Barbuda and Payments (BoP, current US$) of Canada?
Offer a terse response. -4.78e+11. In the year 2009, what is the difference between the Payments (BoP, current US$) in Antigua and Barbuda and Payments (BoP, current US$) in United Kingdom?
Give a very brief answer. -9.44e+11. In the year 2009, what is the difference between the Payments (BoP, current US$) of Belgium and Payments (BoP, current US$) of Canada?
Offer a terse response. -7.25e+1. In the year 2009, what is the difference between the Payments (BoP, current US$) of Belgium and Payments (BoP, current US$) of United Kingdom?
Provide a short and direct response. -5.38e+11. In the year 2009, what is the difference between the Payments (BoP, current US$) of Canada and Payments (BoP, current US$) of United Kingdom?
Provide a succinct answer. -4.65e+11. In the year 2010, what is the difference between the Payments (BoP, current US$) in Antigua and Barbuda and Payments (BoP, current US$) in Belgium?
Provide a short and direct response. -4.25e+11. In the year 2010, what is the difference between the Payments (BoP, current US$) of Antigua and Barbuda and Payments (BoP, current US$) of Canada?
Make the answer very short. -5.83e+11. In the year 2010, what is the difference between the Payments (BoP, current US$) in Antigua and Barbuda and Payments (BoP, current US$) in United Kingdom?
Ensure brevity in your answer.  -9.96e+11. In the year 2010, what is the difference between the Payments (BoP, current US$) in Belgium and Payments (BoP, current US$) in Canada?
Offer a very short reply. -1.58e+11. In the year 2010, what is the difference between the Payments (BoP, current US$) of Belgium and Payments (BoP, current US$) of United Kingdom?
Your answer should be compact. -5.71e+11. In the year 2010, what is the difference between the Payments (BoP, current US$) in Canada and Payments (BoP, current US$) in United Kingdom?
Make the answer very short. -4.13e+11. In the year 2011, what is the difference between the Payments (BoP, current US$) in Antigua and Barbuda and Payments (BoP, current US$) in Belgium?
Provide a short and direct response. -4.95e+11. In the year 2011, what is the difference between the Payments (BoP, current US$) in Antigua and Barbuda and Payments (BoP, current US$) in Canada?
Your answer should be very brief. -6.61e+11. In the year 2011, what is the difference between the Payments (BoP, current US$) of Antigua and Barbuda and Payments (BoP, current US$) of United Kingdom?
Offer a terse response. -1.14e+12. In the year 2011, what is the difference between the Payments (BoP, current US$) in Belgium and Payments (BoP, current US$) in Canada?
Your answer should be compact. -1.66e+11. In the year 2011, what is the difference between the Payments (BoP, current US$) in Belgium and Payments (BoP, current US$) in United Kingdom?
Keep it short and to the point. -6.40e+11. In the year 2011, what is the difference between the Payments (BoP, current US$) in Canada and Payments (BoP, current US$) in United Kingdom?
Ensure brevity in your answer.  -4.74e+11. What is the ratio of the Payments (BoP, current US$) of Antigua and Barbuda in 2005 to that in 2006?
Keep it short and to the point. 0.83. What is the ratio of the Payments (BoP, current US$) in Belgium in 2005 to that in 2006?
Provide a succinct answer. 0.9. What is the ratio of the Payments (BoP, current US$) in Canada in 2005 to that in 2006?
Your answer should be very brief. 0.89. What is the ratio of the Payments (BoP, current US$) in United Kingdom in 2005 to that in 2006?
Your answer should be very brief. 0.81. What is the ratio of the Payments (BoP, current US$) of Antigua and Barbuda in 2005 to that in 2007?
Provide a succinct answer. 0.73. What is the ratio of the Payments (BoP, current US$) of Belgium in 2005 to that in 2007?
Offer a very short reply. 0.74. What is the ratio of the Payments (BoP, current US$) of Canada in 2005 to that in 2007?
Provide a succinct answer. 0.8. What is the ratio of the Payments (BoP, current US$) in United Kingdom in 2005 to that in 2007?
Make the answer very short. 0.69. What is the ratio of the Payments (BoP, current US$) of Antigua and Barbuda in 2005 to that in 2008?
Your answer should be very brief. 0.72. What is the ratio of the Payments (BoP, current US$) of Belgium in 2005 to that in 2008?
Keep it short and to the point. 0.64. What is the ratio of the Payments (BoP, current US$) of Canada in 2005 to that in 2008?
Offer a very short reply. 0.75. What is the ratio of the Payments (BoP, current US$) of United Kingdom in 2005 to that in 2008?
Provide a short and direct response. 0.7. What is the ratio of the Payments (BoP, current US$) of Antigua and Barbuda in 2005 to that in 2009?
Make the answer very short. 0.96. What is the ratio of the Payments (BoP, current US$) of Belgium in 2005 to that in 2009?
Your answer should be very brief. 0.81. What is the ratio of the Payments (BoP, current US$) in Canada in 2005 to that in 2009?
Make the answer very short. 0.94. What is the ratio of the Payments (BoP, current US$) in United Kingdom in 2005 to that in 2009?
Make the answer very short. 1.04. What is the ratio of the Payments (BoP, current US$) in Antigua and Barbuda in 2005 to that in 2010?
Offer a very short reply. 1.03. What is the ratio of the Payments (BoP, current US$) of Belgium in 2005 to that in 2010?
Offer a very short reply. 0.78. What is the ratio of the Payments (BoP, current US$) in Canada in 2005 to that in 2010?
Give a very brief answer. 0.77. What is the ratio of the Payments (BoP, current US$) of United Kingdom in 2005 to that in 2010?
Make the answer very short. 0.99. What is the ratio of the Payments (BoP, current US$) of Antigua and Barbuda in 2005 to that in 2011?
Your response must be concise. 1.07. What is the ratio of the Payments (BoP, current US$) in Belgium in 2005 to that in 2011?
Your response must be concise. 0.67. What is the ratio of the Payments (BoP, current US$) of Canada in 2005 to that in 2011?
Make the answer very short. 0.68. What is the ratio of the Payments (BoP, current US$) in United Kingdom in 2005 to that in 2011?
Offer a terse response. 0.87. What is the ratio of the Payments (BoP, current US$) in Antigua and Barbuda in 2006 to that in 2007?
Make the answer very short. 0.88. What is the ratio of the Payments (BoP, current US$) of Belgium in 2006 to that in 2007?
Provide a short and direct response. 0.82. What is the ratio of the Payments (BoP, current US$) in Canada in 2006 to that in 2007?
Make the answer very short. 0.9. What is the ratio of the Payments (BoP, current US$) of United Kingdom in 2006 to that in 2007?
Provide a succinct answer. 0.85. What is the ratio of the Payments (BoP, current US$) in Antigua and Barbuda in 2006 to that in 2008?
Your response must be concise. 0.87. What is the ratio of the Payments (BoP, current US$) of Belgium in 2006 to that in 2008?
Offer a terse response. 0.71. What is the ratio of the Payments (BoP, current US$) in Canada in 2006 to that in 2008?
Give a very brief answer. 0.84. What is the ratio of the Payments (BoP, current US$) of United Kingdom in 2006 to that in 2008?
Your response must be concise. 0.87. What is the ratio of the Payments (BoP, current US$) in Antigua and Barbuda in 2006 to that in 2009?
Make the answer very short. 1.16. What is the ratio of the Payments (BoP, current US$) of Belgium in 2006 to that in 2009?
Ensure brevity in your answer.  0.9. What is the ratio of the Payments (BoP, current US$) in Canada in 2006 to that in 2009?
Ensure brevity in your answer.  1.05. What is the ratio of the Payments (BoP, current US$) of United Kingdom in 2006 to that in 2009?
Offer a very short reply. 1.29. What is the ratio of the Payments (BoP, current US$) in Antigua and Barbuda in 2006 to that in 2010?
Your answer should be compact. 1.24. What is the ratio of the Payments (BoP, current US$) of Belgium in 2006 to that in 2010?
Your answer should be very brief. 0.86. What is the ratio of the Payments (BoP, current US$) of Canada in 2006 to that in 2010?
Offer a terse response. 0.86. What is the ratio of the Payments (BoP, current US$) in United Kingdom in 2006 to that in 2010?
Your answer should be compact. 1.22. What is the ratio of the Payments (BoP, current US$) in Antigua and Barbuda in 2006 to that in 2011?
Offer a very short reply. 1.29. What is the ratio of the Payments (BoP, current US$) of Belgium in 2006 to that in 2011?
Make the answer very short. 0.74. What is the ratio of the Payments (BoP, current US$) of Canada in 2006 to that in 2011?
Your response must be concise. 0.76. What is the ratio of the Payments (BoP, current US$) in United Kingdom in 2006 to that in 2011?
Make the answer very short. 1.07. What is the ratio of the Payments (BoP, current US$) of Antigua and Barbuda in 2007 to that in 2008?
Your response must be concise. 0.98. What is the ratio of the Payments (BoP, current US$) of Belgium in 2007 to that in 2008?
Your answer should be very brief. 0.87. What is the ratio of the Payments (BoP, current US$) of Canada in 2007 to that in 2008?
Ensure brevity in your answer.  0.94. What is the ratio of the Payments (BoP, current US$) in United Kingdom in 2007 to that in 2008?
Make the answer very short. 1.02. What is the ratio of the Payments (BoP, current US$) of Antigua and Barbuda in 2007 to that in 2009?
Your answer should be very brief. 1.31. What is the ratio of the Payments (BoP, current US$) in Belgium in 2007 to that in 2009?
Provide a short and direct response. 1.1. What is the ratio of the Payments (BoP, current US$) in Canada in 2007 to that in 2009?
Your answer should be compact. 1.17. What is the ratio of the Payments (BoP, current US$) in United Kingdom in 2007 to that in 2009?
Ensure brevity in your answer.  1.52. What is the ratio of the Payments (BoP, current US$) of Antigua and Barbuda in 2007 to that in 2010?
Provide a short and direct response. 1.4. What is the ratio of the Payments (BoP, current US$) in Belgium in 2007 to that in 2010?
Provide a short and direct response. 1.05. What is the ratio of the Payments (BoP, current US$) in Canada in 2007 to that in 2010?
Offer a very short reply. 0.96. What is the ratio of the Payments (BoP, current US$) in United Kingdom in 2007 to that in 2010?
Offer a very short reply. 1.44. What is the ratio of the Payments (BoP, current US$) of Antigua and Barbuda in 2007 to that in 2011?
Offer a terse response. 1.46. What is the ratio of the Payments (BoP, current US$) of Belgium in 2007 to that in 2011?
Provide a short and direct response. 0.9. What is the ratio of the Payments (BoP, current US$) in Canada in 2007 to that in 2011?
Your answer should be very brief. 0.85. What is the ratio of the Payments (BoP, current US$) of United Kingdom in 2007 to that in 2011?
Ensure brevity in your answer.  1.27. What is the ratio of the Payments (BoP, current US$) of Antigua and Barbuda in 2008 to that in 2009?
Your answer should be compact. 1.34. What is the ratio of the Payments (BoP, current US$) in Belgium in 2008 to that in 2009?
Give a very brief answer. 1.27. What is the ratio of the Payments (BoP, current US$) of Canada in 2008 to that in 2009?
Ensure brevity in your answer.  1.25. What is the ratio of the Payments (BoP, current US$) in United Kingdom in 2008 to that in 2009?
Your answer should be very brief. 1.49. What is the ratio of the Payments (BoP, current US$) of Antigua and Barbuda in 2008 to that in 2010?
Provide a succinct answer. 1.43. What is the ratio of the Payments (BoP, current US$) in Belgium in 2008 to that in 2010?
Your answer should be very brief. 1.22. What is the ratio of the Payments (BoP, current US$) of Canada in 2008 to that in 2010?
Your response must be concise. 1.02. What is the ratio of the Payments (BoP, current US$) in United Kingdom in 2008 to that in 2010?
Provide a short and direct response. 1.41. What is the ratio of the Payments (BoP, current US$) in Antigua and Barbuda in 2008 to that in 2011?
Keep it short and to the point. 1.49. What is the ratio of the Payments (BoP, current US$) of Belgium in 2008 to that in 2011?
Your answer should be very brief. 1.04. What is the ratio of the Payments (BoP, current US$) in Canada in 2008 to that in 2011?
Provide a short and direct response. 0.9. What is the ratio of the Payments (BoP, current US$) of United Kingdom in 2008 to that in 2011?
Offer a terse response. 1.24. What is the ratio of the Payments (BoP, current US$) of Antigua and Barbuda in 2009 to that in 2010?
Provide a short and direct response. 1.07. What is the ratio of the Payments (BoP, current US$) of Belgium in 2009 to that in 2010?
Give a very brief answer. 0.95. What is the ratio of the Payments (BoP, current US$) of Canada in 2009 to that in 2010?
Offer a very short reply. 0.82. What is the ratio of the Payments (BoP, current US$) of Antigua and Barbuda in 2009 to that in 2011?
Your answer should be compact. 1.11. What is the ratio of the Payments (BoP, current US$) in Belgium in 2009 to that in 2011?
Your answer should be compact. 0.82. What is the ratio of the Payments (BoP, current US$) in Canada in 2009 to that in 2011?
Your answer should be very brief. 0.72. What is the ratio of the Payments (BoP, current US$) of United Kingdom in 2009 to that in 2011?
Offer a very short reply. 0.83. What is the ratio of the Payments (BoP, current US$) of Antigua and Barbuda in 2010 to that in 2011?
Your answer should be very brief. 1.04. What is the ratio of the Payments (BoP, current US$) in Belgium in 2010 to that in 2011?
Keep it short and to the point. 0.86. What is the ratio of the Payments (BoP, current US$) of Canada in 2010 to that in 2011?
Provide a succinct answer. 0.88. What is the ratio of the Payments (BoP, current US$) in United Kingdom in 2010 to that in 2011?
Your response must be concise. 0.88. What is the difference between the highest and the second highest Payments (BoP, current US$) of Antigua and Barbuda?
Your answer should be very brief. 1.86e+07. What is the difference between the highest and the second highest Payments (BoP, current US$) of Belgium?
Make the answer very short. 2.17e+1. What is the difference between the highest and the second highest Payments (BoP, current US$) in Canada?
Make the answer very short. 6.38e+1. What is the difference between the highest and the second highest Payments (BoP, current US$) in United Kingdom?
Offer a terse response. 3.47e+1. What is the difference between the highest and the lowest Payments (BoP, current US$) of Antigua and Barbuda?
Your answer should be very brief. 3.38e+08. What is the difference between the highest and the lowest Payments (BoP, current US$) in Belgium?
Provide a succinct answer. 1.87e+11. What is the difference between the highest and the lowest Payments (BoP, current US$) of Canada?
Offer a very short reply. 2.13e+11. What is the difference between the highest and the lowest Payments (BoP, current US$) of United Kingdom?
Ensure brevity in your answer.  4.94e+11. 